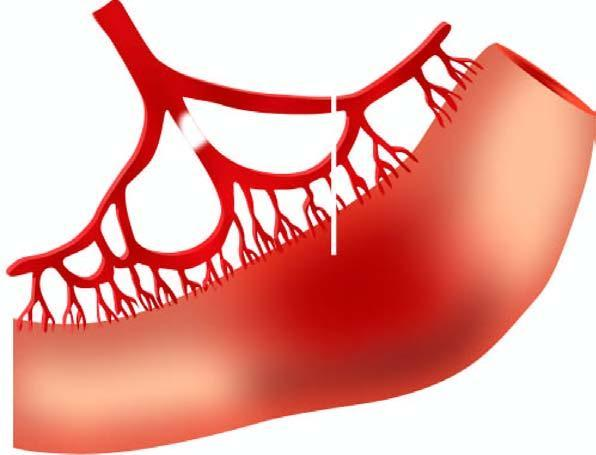s line of demarcation between gangrenous segment and the viable bowel not clear-cut?
Answer the question using a single word or phrase. Yes 